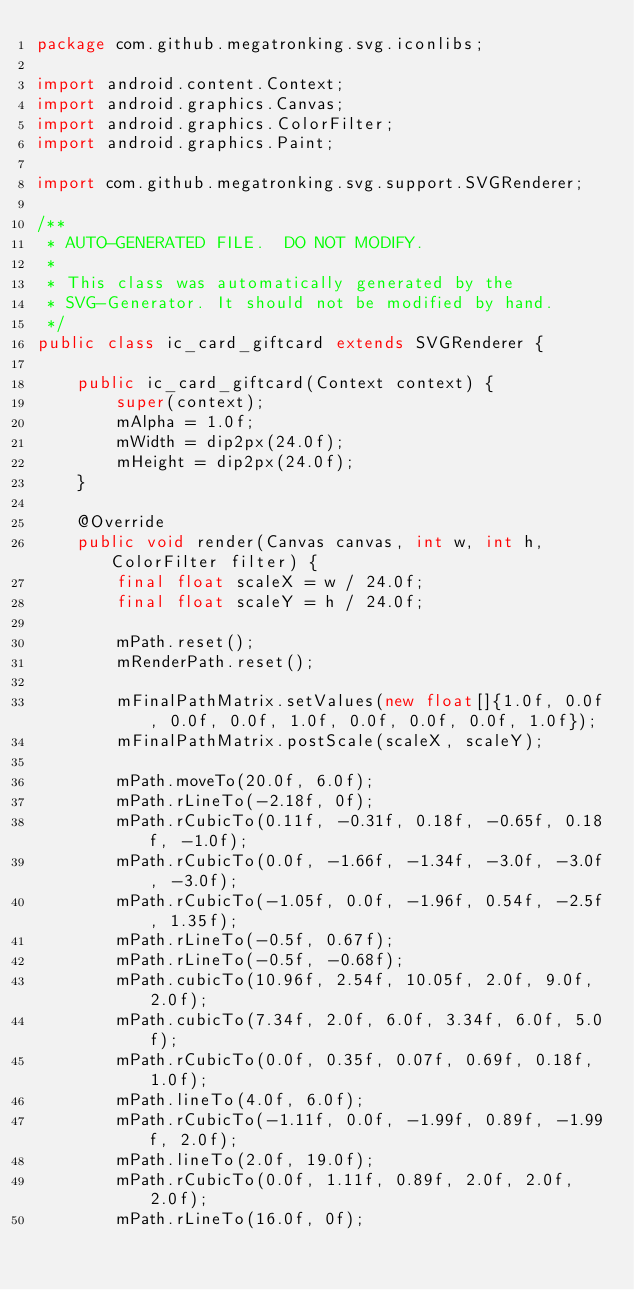<code> <loc_0><loc_0><loc_500><loc_500><_Java_>package com.github.megatronking.svg.iconlibs;

import android.content.Context;
import android.graphics.Canvas;
import android.graphics.ColorFilter;
import android.graphics.Paint;

import com.github.megatronking.svg.support.SVGRenderer;

/**
 * AUTO-GENERATED FILE.  DO NOT MODIFY.
 * 
 * This class was automatically generated by the
 * SVG-Generator. It should not be modified by hand.
 */
public class ic_card_giftcard extends SVGRenderer {

    public ic_card_giftcard(Context context) {
        super(context);
        mAlpha = 1.0f;
        mWidth = dip2px(24.0f);
        mHeight = dip2px(24.0f);
    }

    @Override
    public void render(Canvas canvas, int w, int h, ColorFilter filter) {
        final float scaleX = w / 24.0f;
        final float scaleY = h / 24.0f;
        
        mPath.reset();
        mRenderPath.reset();
        
        mFinalPathMatrix.setValues(new float[]{1.0f, 0.0f, 0.0f, 0.0f, 1.0f, 0.0f, 0.0f, 0.0f, 1.0f});
        mFinalPathMatrix.postScale(scaleX, scaleY);
        
        mPath.moveTo(20.0f, 6.0f);
        mPath.rLineTo(-2.18f, 0f);
        mPath.rCubicTo(0.11f, -0.31f, 0.18f, -0.65f, 0.18f, -1.0f);
        mPath.rCubicTo(0.0f, -1.66f, -1.34f, -3.0f, -3.0f, -3.0f);
        mPath.rCubicTo(-1.05f, 0.0f, -1.96f, 0.54f, -2.5f, 1.35f);
        mPath.rLineTo(-0.5f, 0.67f);
        mPath.rLineTo(-0.5f, -0.68f);
        mPath.cubicTo(10.96f, 2.54f, 10.05f, 2.0f, 9.0f, 2.0f);
        mPath.cubicTo(7.34f, 2.0f, 6.0f, 3.34f, 6.0f, 5.0f);
        mPath.rCubicTo(0.0f, 0.35f, 0.07f, 0.69f, 0.18f, 1.0f);
        mPath.lineTo(4.0f, 6.0f);
        mPath.rCubicTo(-1.11f, 0.0f, -1.99f, 0.89f, -1.99f, 2.0f);
        mPath.lineTo(2.0f, 19.0f);
        mPath.rCubicTo(0.0f, 1.11f, 0.89f, 2.0f, 2.0f, 2.0f);
        mPath.rLineTo(16.0f, 0f);</code> 